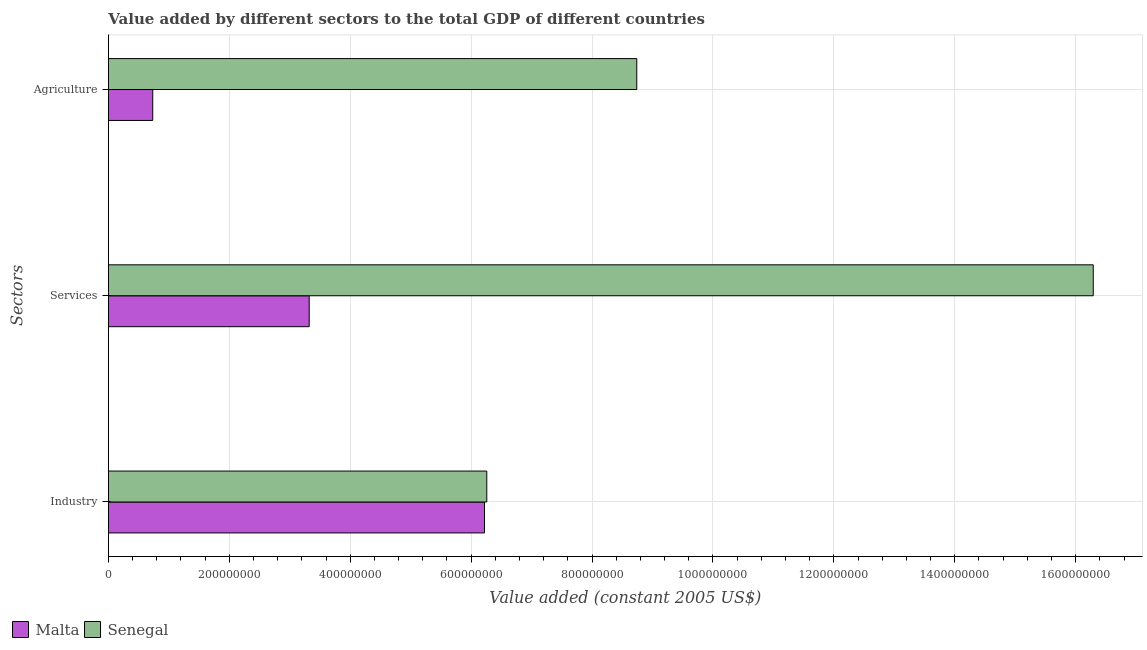How many groups of bars are there?
Make the answer very short. 3. Are the number of bars per tick equal to the number of legend labels?
Keep it short and to the point. Yes. Are the number of bars on each tick of the Y-axis equal?
Your answer should be compact. Yes. How many bars are there on the 2nd tick from the top?
Offer a terse response. 2. How many bars are there on the 3rd tick from the bottom?
Offer a very short reply. 2. What is the label of the 1st group of bars from the top?
Your answer should be very brief. Agriculture. What is the value added by agricultural sector in Senegal?
Provide a succinct answer. 8.74e+08. Across all countries, what is the maximum value added by agricultural sector?
Make the answer very short. 8.74e+08. Across all countries, what is the minimum value added by agricultural sector?
Make the answer very short. 7.33e+07. In which country was the value added by industrial sector maximum?
Ensure brevity in your answer.  Senegal. In which country was the value added by industrial sector minimum?
Your response must be concise. Malta. What is the total value added by services in the graph?
Your response must be concise. 1.96e+09. What is the difference between the value added by industrial sector in Senegal and that in Malta?
Give a very brief answer. 3.77e+06. What is the difference between the value added by services in Senegal and the value added by industrial sector in Malta?
Ensure brevity in your answer.  1.01e+09. What is the average value added by agricultural sector per country?
Ensure brevity in your answer.  4.74e+08. What is the difference between the value added by services and value added by industrial sector in Senegal?
Ensure brevity in your answer.  1.00e+09. In how many countries, is the value added by industrial sector greater than 680000000 US$?
Offer a very short reply. 0. What is the ratio of the value added by agricultural sector in Malta to that in Senegal?
Your answer should be compact. 0.08. What is the difference between the highest and the second highest value added by agricultural sector?
Ensure brevity in your answer.  8.01e+08. What is the difference between the highest and the lowest value added by industrial sector?
Your answer should be very brief. 3.77e+06. In how many countries, is the value added by industrial sector greater than the average value added by industrial sector taken over all countries?
Make the answer very short. 1. What does the 1st bar from the top in Services represents?
Ensure brevity in your answer.  Senegal. What does the 2nd bar from the bottom in Agriculture represents?
Give a very brief answer. Senegal. What is the difference between two consecutive major ticks on the X-axis?
Provide a succinct answer. 2.00e+08. Are the values on the major ticks of X-axis written in scientific E-notation?
Your response must be concise. No. Does the graph contain any zero values?
Offer a very short reply. No. How many legend labels are there?
Your answer should be very brief. 2. What is the title of the graph?
Provide a short and direct response. Value added by different sectors to the total GDP of different countries. What is the label or title of the X-axis?
Make the answer very short. Value added (constant 2005 US$). What is the label or title of the Y-axis?
Ensure brevity in your answer.  Sectors. What is the Value added (constant 2005 US$) in Malta in Industry?
Keep it short and to the point. 6.22e+08. What is the Value added (constant 2005 US$) of Senegal in Industry?
Offer a very short reply. 6.26e+08. What is the Value added (constant 2005 US$) in Malta in Services?
Your answer should be compact. 3.32e+08. What is the Value added (constant 2005 US$) in Senegal in Services?
Offer a very short reply. 1.63e+09. What is the Value added (constant 2005 US$) in Malta in Agriculture?
Your answer should be very brief. 7.33e+07. What is the Value added (constant 2005 US$) in Senegal in Agriculture?
Give a very brief answer. 8.74e+08. Across all Sectors, what is the maximum Value added (constant 2005 US$) in Malta?
Give a very brief answer. 6.22e+08. Across all Sectors, what is the maximum Value added (constant 2005 US$) of Senegal?
Your answer should be very brief. 1.63e+09. Across all Sectors, what is the minimum Value added (constant 2005 US$) of Malta?
Provide a succinct answer. 7.33e+07. Across all Sectors, what is the minimum Value added (constant 2005 US$) in Senegal?
Provide a short and direct response. 6.26e+08. What is the total Value added (constant 2005 US$) of Malta in the graph?
Provide a short and direct response. 1.03e+09. What is the total Value added (constant 2005 US$) of Senegal in the graph?
Your answer should be very brief. 3.13e+09. What is the difference between the Value added (constant 2005 US$) in Malta in Industry and that in Services?
Your answer should be very brief. 2.90e+08. What is the difference between the Value added (constant 2005 US$) of Senegal in Industry and that in Services?
Make the answer very short. -1.00e+09. What is the difference between the Value added (constant 2005 US$) in Malta in Industry and that in Agriculture?
Give a very brief answer. 5.49e+08. What is the difference between the Value added (constant 2005 US$) in Senegal in Industry and that in Agriculture?
Offer a very short reply. -2.48e+08. What is the difference between the Value added (constant 2005 US$) of Malta in Services and that in Agriculture?
Offer a terse response. 2.59e+08. What is the difference between the Value added (constant 2005 US$) of Senegal in Services and that in Agriculture?
Ensure brevity in your answer.  7.55e+08. What is the difference between the Value added (constant 2005 US$) in Malta in Industry and the Value added (constant 2005 US$) in Senegal in Services?
Give a very brief answer. -1.01e+09. What is the difference between the Value added (constant 2005 US$) in Malta in Industry and the Value added (constant 2005 US$) in Senegal in Agriculture?
Offer a terse response. -2.52e+08. What is the difference between the Value added (constant 2005 US$) of Malta in Services and the Value added (constant 2005 US$) of Senegal in Agriculture?
Keep it short and to the point. -5.42e+08. What is the average Value added (constant 2005 US$) in Malta per Sectors?
Ensure brevity in your answer.  3.43e+08. What is the average Value added (constant 2005 US$) of Senegal per Sectors?
Ensure brevity in your answer.  1.04e+09. What is the difference between the Value added (constant 2005 US$) of Malta and Value added (constant 2005 US$) of Senegal in Industry?
Offer a very short reply. -3.77e+06. What is the difference between the Value added (constant 2005 US$) of Malta and Value added (constant 2005 US$) of Senegal in Services?
Your answer should be compact. -1.30e+09. What is the difference between the Value added (constant 2005 US$) in Malta and Value added (constant 2005 US$) in Senegal in Agriculture?
Ensure brevity in your answer.  -8.01e+08. What is the ratio of the Value added (constant 2005 US$) of Malta in Industry to that in Services?
Provide a short and direct response. 1.87. What is the ratio of the Value added (constant 2005 US$) of Senegal in Industry to that in Services?
Ensure brevity in your answer.  0.38. What is the ratio of the Value added (constant 2005 US$) in Malta in Industry to that in Agriculture?
Keep it short and to the point. 8.49. What is the ratio of the Value added (constant 2005 US$) in Senegal in Industry to that in Agriculture?
Make the answer very short. 0.72. What is the ratio of the Value added (constant 2005 US$) in Malta in Services to that in Agriculture?
Offer a terse response. 4.53. What is the ratio of the Value added (constant 2005 US$) in Senegal in Services to that in Agriculture?
Your response must be concise. 1.86. What is the difference between the highest and the second highest Value added (constant 2005 US$) of Malta?
Your response must be concise. 2.90e+08. What is the difference between the highest and the second highest Value added (constant 2005 US$) in Senegal?
Provide a succinct answer. 7.55e+08. What is the difference between the highest and the lowest Value added (constant 2005 US$) in Malta?
Provide a succinct answer. 5.49e+08. What is the difference between the highest and the lowest Value added (constant 2005 US$) in Senegal?
Ensure brevity in your answer.  1.00e+09. 